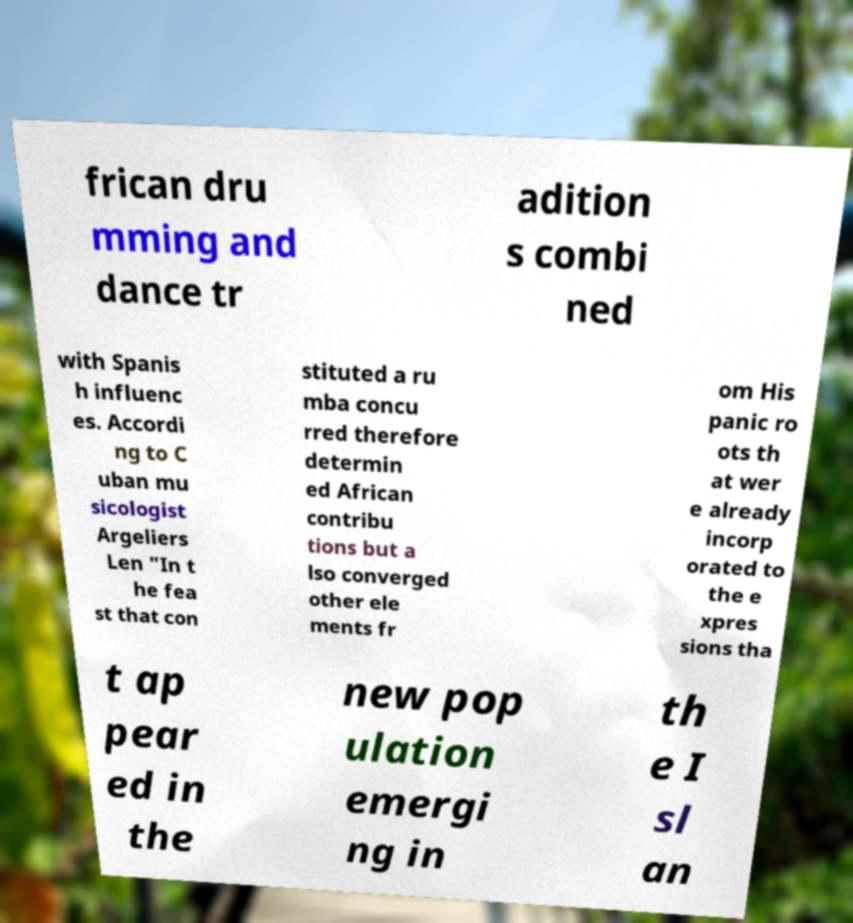Can you accurately transcribe the text from the provided image for me? frican dru mming and dance tr adition s combi ned with Spanis h influenc es. Accordi ng to C uban mu sicologist Argeliers Len "In t he fea st that con stituted a ru mba concu rred therefore determin ed African contribu tions but a lso converged other ele ments fr om His panic ro ots th at wer e already incorp orated to the e xpres sions tha t ap pear ed in the new pop ulation emergi ng in th e I sl an 